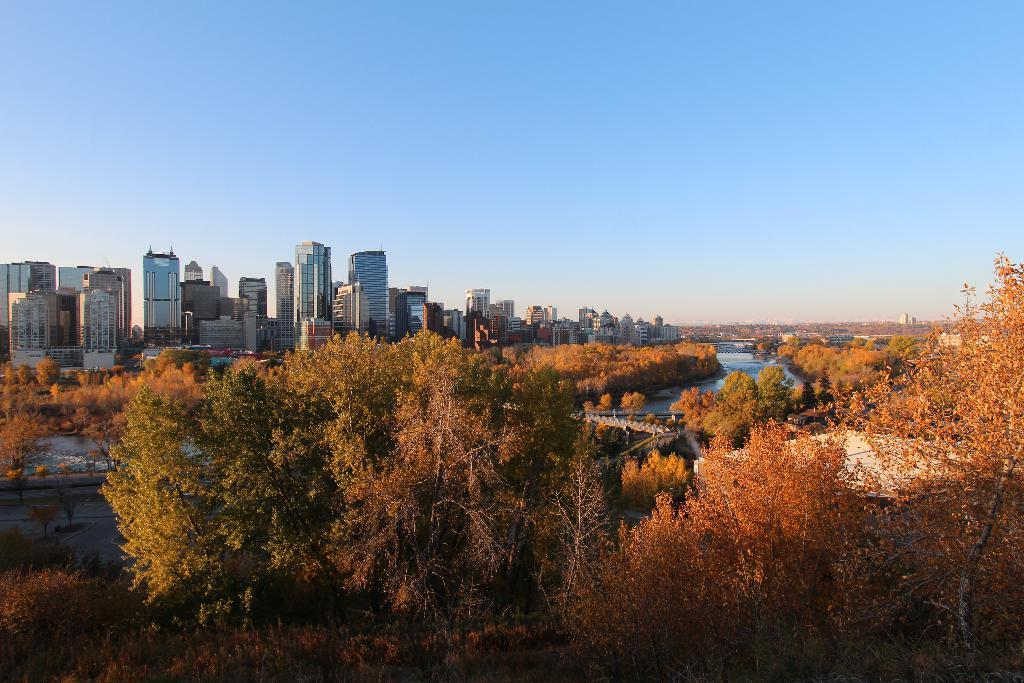What type of structures are visible in the image? There are tall buildings in the image. What other natural elements can be seen in the image? There are plenty of trees in the image. How are the trees positioned in relation to the tall buildings? The trees are in front of the tall buildings. What body of water is present in the image? There is a river between the trees. What type of nut can be seen growing on the trees in the image? There is no nut visible on the trees in the image. What kind of rock formation can be seen near the river in the image? There is no rock formation visible near the river in the image. 